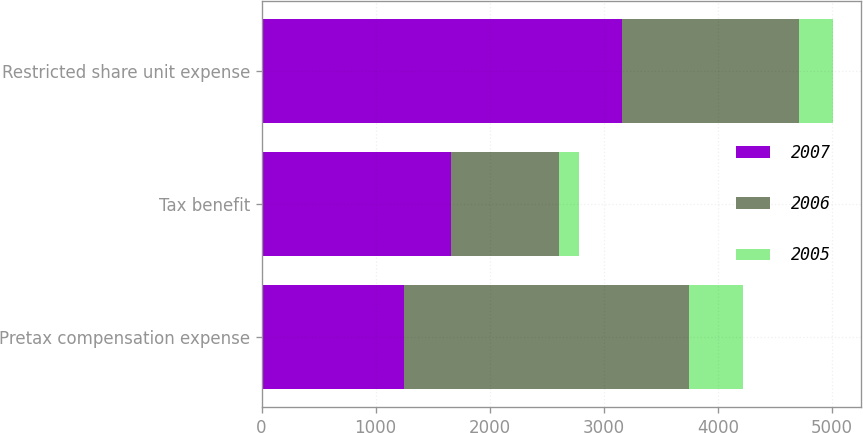<chart> <loc_0><loc_0><loc_500><loc_500><stacked_bar_chart><ecel><fcel>Pretax compensation expense<fcel>Tax benefit<fcel>Restricted share unit expense<nl><fcel>2007<fcel>1248<fcel>1660<fcel>3160<nl><fcel>2006<fcel>2496<fcel>946<fcel>1550<nl><fcel>2005<fcel>479<fcel>181<fcel>298<nl></chart> 